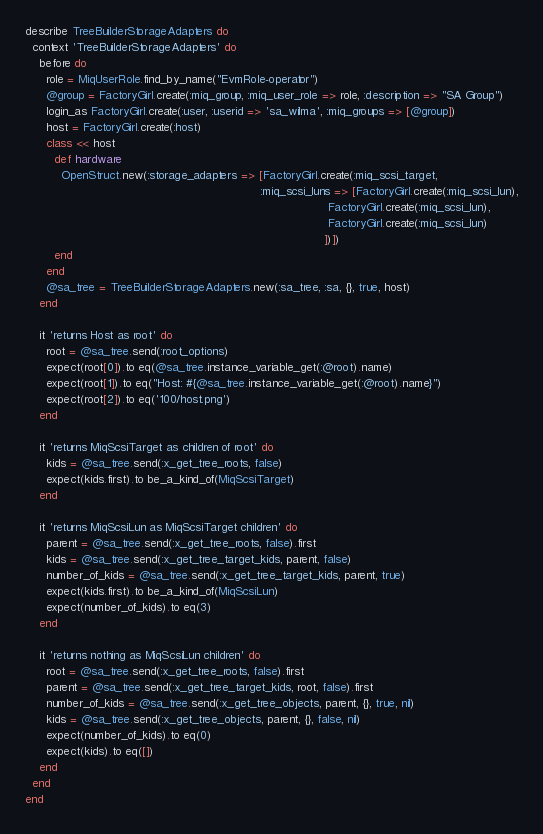Convert code to text. <code><loc_0><loc_0><loc_500><loc_500><_Ruby_>describe TreeBuilderStorageAdapters do
  context 'TreeBuilderStorageAdapters' do
    before do
      role = MiqUserRole.find_by_name("EvmRole-operator")
      @group = FactoryGirl.create(:miq_group, :miq_user_role => role, :description => "SA Group")
      login_as FactoryGirl.create(:user, :userid => 'sa_wilma', :miq_groups => [@group])
      host = FactoryGirl.create(:host)
      class << host
        def hardware
          OpenStruct.new(:storage_adapters => [FactoryGirl.create(:miq_scsi_target,
                                                                  :miq_scsi_luns => [FactoryGirl.create(:miq_scsi_lun),
                                                                                     FactoryGirl.create(:miq_scsi_lun),
                                                                                     FactoryGirl.create(:miq_scsi_lun)
                                                                                    ])])
        end
      end
      @sa_tree = TreeBuilderStorageAdapters.new(:sa_tree, :sa, {}, true, host)
    end

    it 'returns Host as root' do
      root = @sa_tree.send(:root_options)
      expect(root[0]).to eq(@sa_tree.instance_variable_get(:@root).name)
      expect(root[1]).to eq("Host: #{@sa_tree.instance_variable_get(:@root).name}")
      expect(root[2]).to eq('100/host.png')
    end

    it 'returns MiqScsiTarget as children of root' do
      kids = @sa_tree.send(:x_get_tree_roots, false)
      expect(kids.first).to be_a_kind_of(MiqScsiTarget)
    end

    it 'returns MiqScsiLun as MiqScsiTarget children' do
      parent = @sa_tree.send(:x_get_tree_roots, false).first
      kids = @sa_tree.send(:x_get_tree_target_kids, parent, false)
      number_of_kids = @sa_tree.send(:x_get_tree_target_kids, parent, true)
      expect(kids.first).to be_a_kind_of(MiqScsiLun)
      expect(number_of_kids).to eq(3)
    end

    it 'returns nothing as MiqScsiLun children' do
      root = @sa_tree.send(:x_get_tree_roots, false).first
      parent = @sa_tree.send(:x_get_tree_target_kids, root, false).first
      number_of_kids = @sa_tree.send(:x_get_tree_objects, parent, {}, true, nil)
      kids = @sa_tree.send(:x_get_tree_objects, parent, {}, false, nil)
      expect(number_of_kids).to eq(0)
      expect(kids).to eq([])
    end
  end
end
</code> 